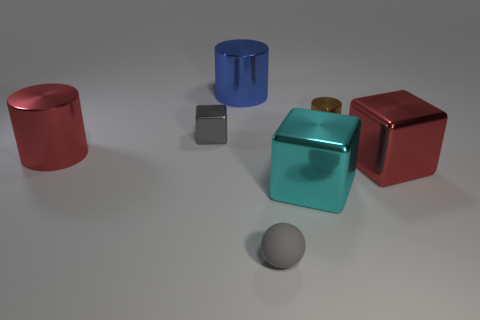Add 3 metal cubes. How many objects exist? 10 Subtract all blocks. How many objects are left? 4 Add 6 big cyan metal cubes. How many big cyan metal cubes are left? 7 Add 3 big rubber spheres. How many big rubber spheres exist? 3 Subtract 0 brown balls. How many objects are left? 7 Subtract all cyan shiny things. Subtract all tiny gray rubber things. How many objects are left? 5 